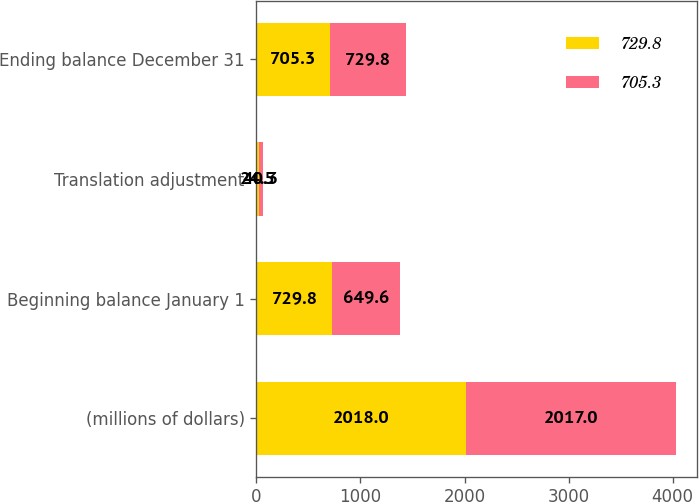<chart> <loc_0><loc_0><loc_500><loc_500><stacked_bar_chart><ecel><fcel>(millions of dollars)<fcel>Beginning balance January 1<fcel>Translation adjustment<fcel>Ending balance December 31<nl><fcel>729.8<fcel>2018<fcel>729.8<fcel>24.5<fcel>705.3<nl><fcel>705.3<fcel>2017<fcel>649.6<fcel>40.3<fcel>729.8<nl></chart> 